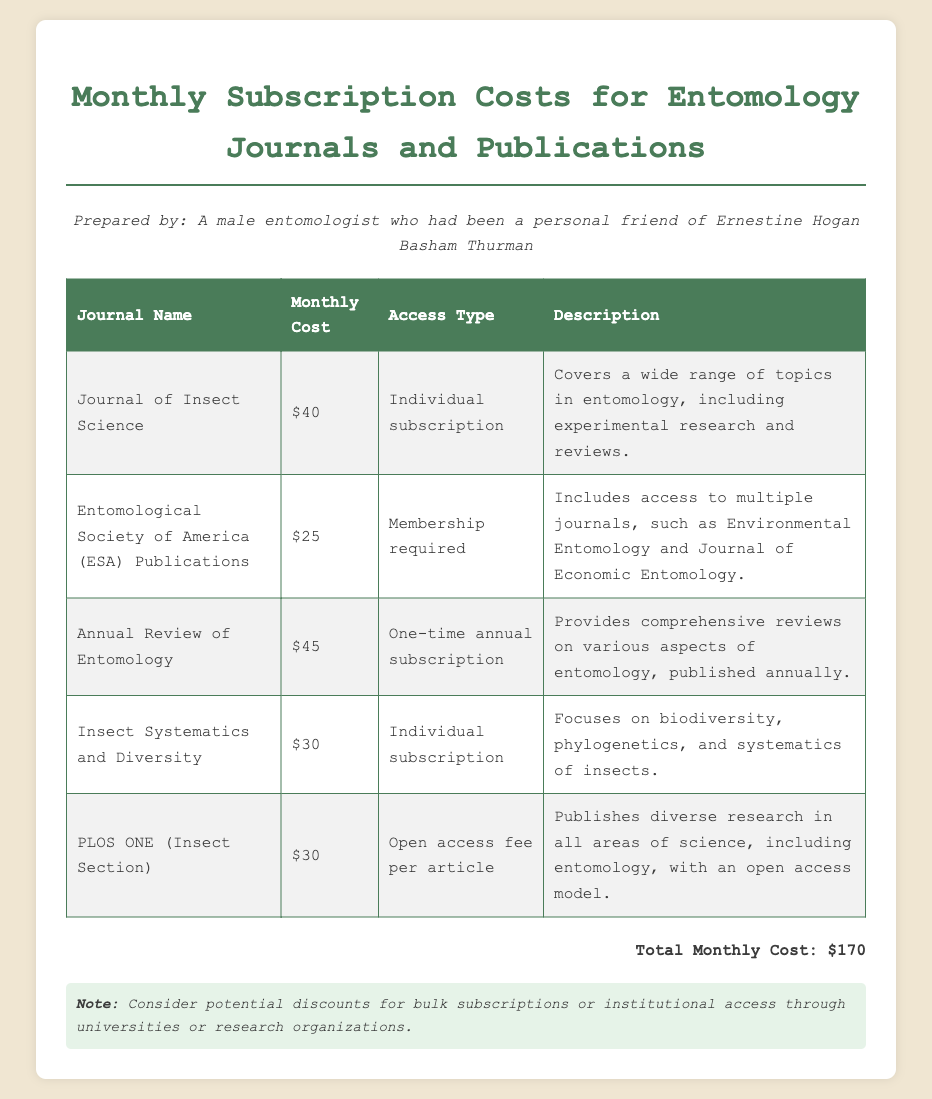What is the monthly cost for the Journal of Insect Science? The monthly cost for the Journal of Insect Science is specifically listed in the document.
Answer: $40 What is the access type for ESA Publications? The access type is indicated in the document and specifies that membership is required.
Answer: Membership required How much does PLOS ONE charge per article? The document states the cost associated with PLOS ONE’s insect section as an open access fee per article.
Answer: $30 What is the total monthly cost for all journals listed? The total monthly cost is clearly calculated and presented in the document.
Answer: $170 What is the monthly subscription cost for the Annual Review of Entomology? The document provides the specific price for this journal, reflecting its monthly subscription rate.
Answer: $45 What kind of topics does the Journal of Insect Science cover? The document describes the range of topics discussed in the journal, indicating its breadth.
Answer: Wide range of topics in entomology What is the description for Insect Systematics and Diversity? The document includes the description for this journal, highlighting its focus areas.
Answer: Biodiversity, phylogenetics, and systematics of insects Is the Annual Review of Entomology a monthly subscription? The document specifies the subscription type and duration for this publication.
Answer: One-time annual subscription What is a potential consideration mentioned in the notes? The notes section suggests a consideration that may affect subscription choices.
Answer: Discounts for bulk subscriptions 